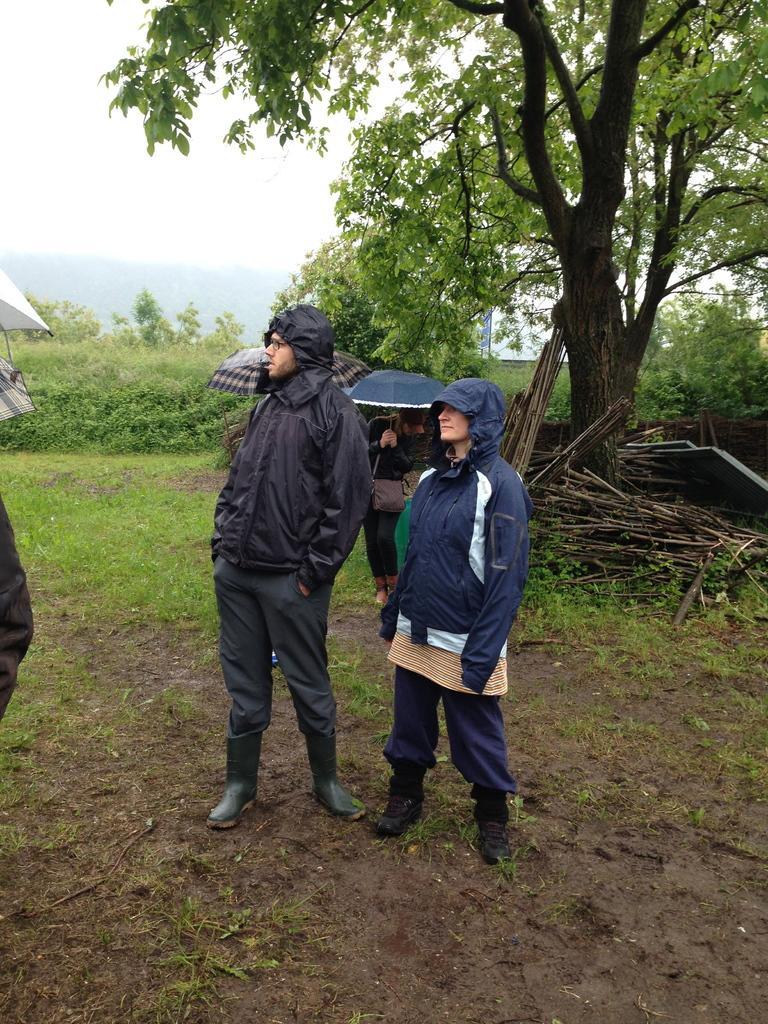Describe this image in one or two sentences. This picture might be taken from outside of the city. In this image, in the middle, we can see two people man and woman are standing on the land. On the right side, we can see some trees, plants and some wood sticks. On the left side, we can see a person. In the background, we can see two people are standing under the umbrella. In the background, we can see some trees, plants, windows. At the top, we can see a sky, at the bottom, we can see a grass on the land. 